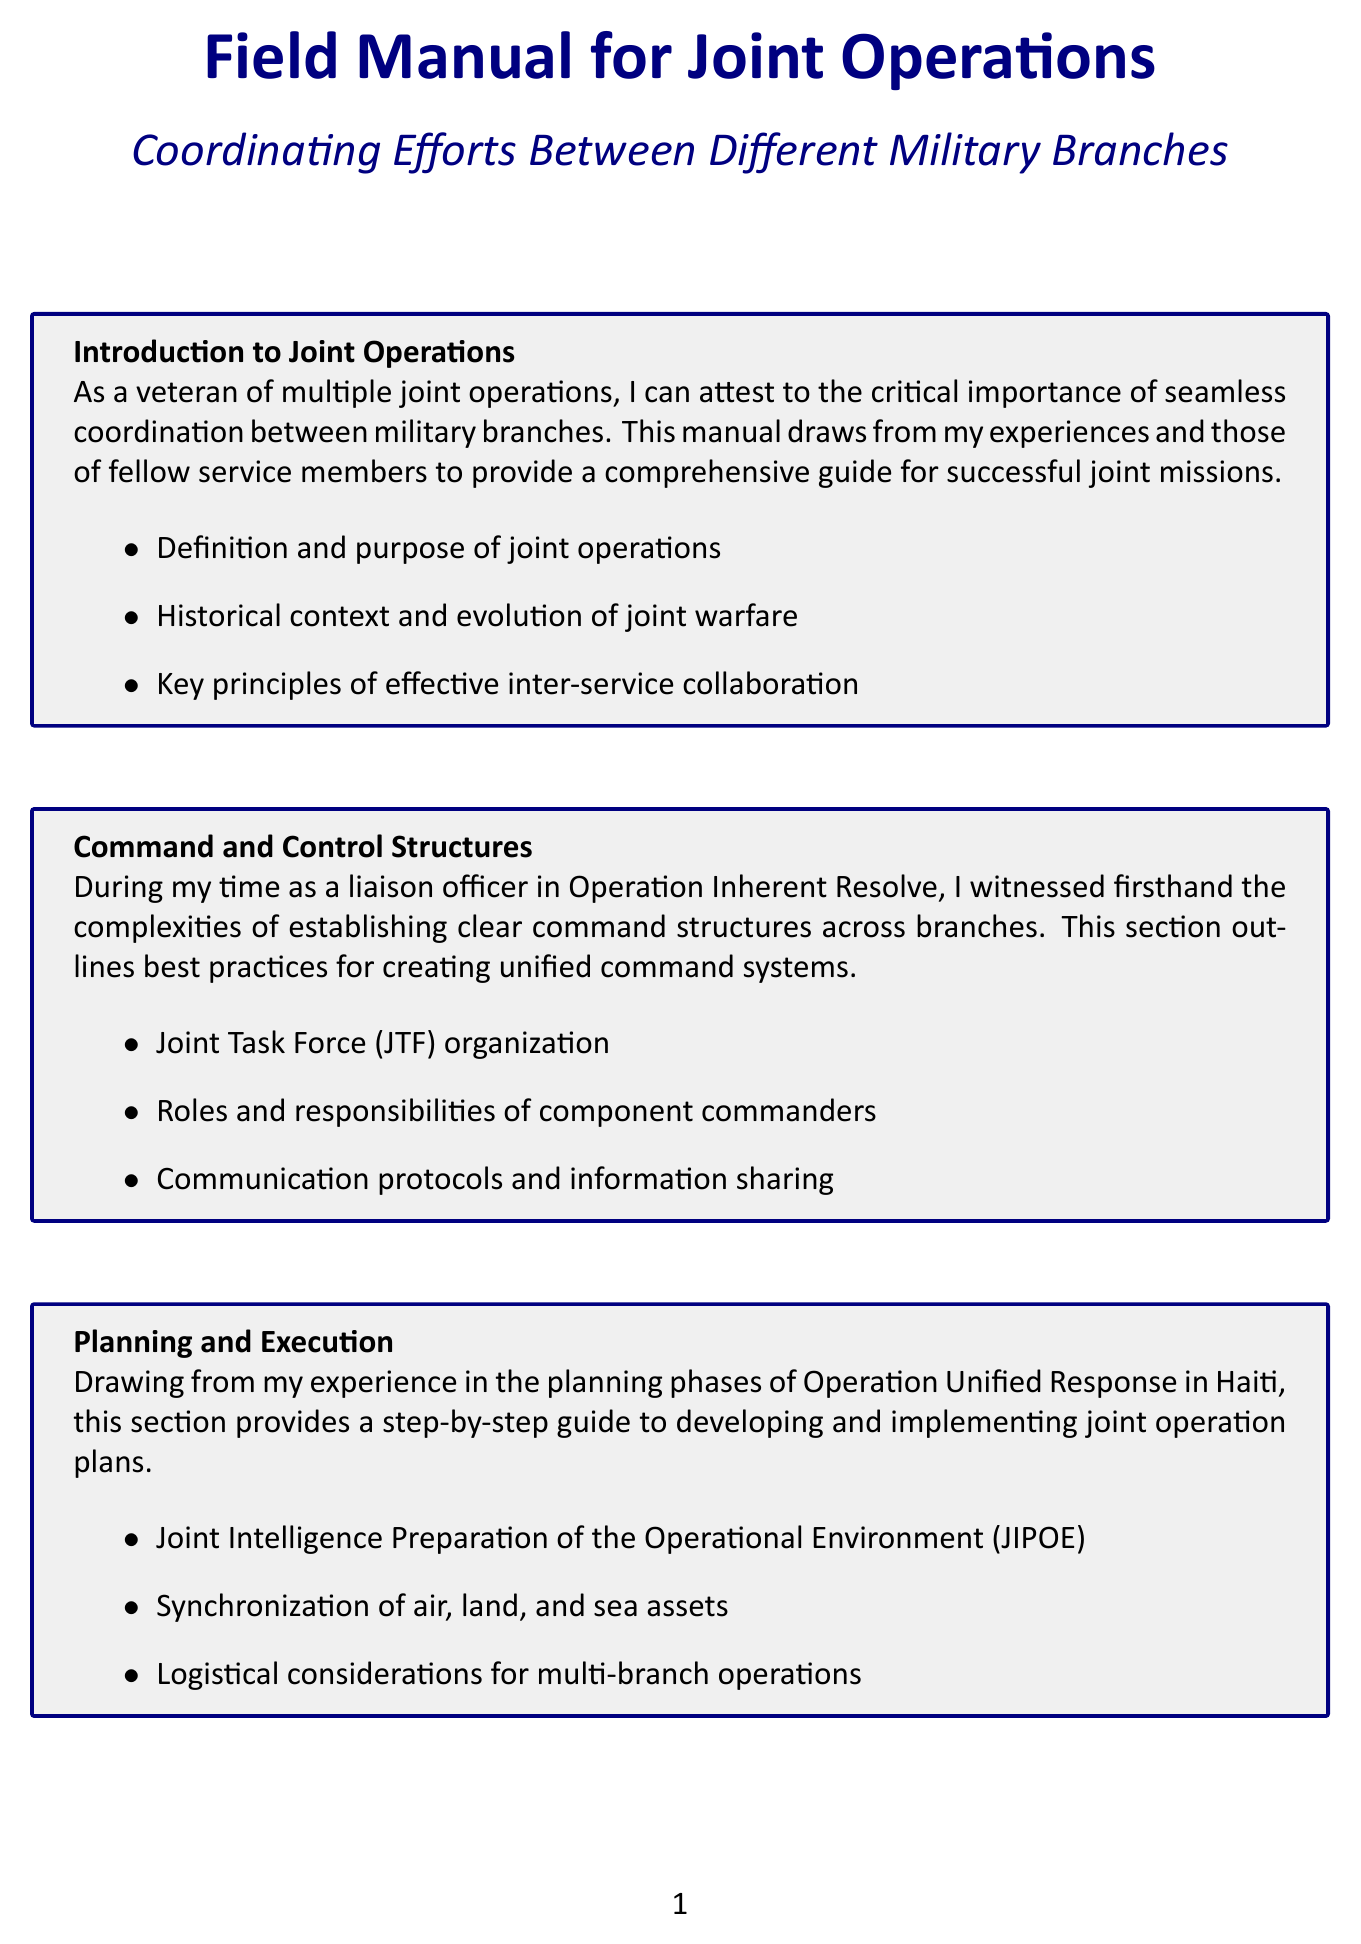What is the title of the manual? The title of the manual is stated at the beginning of the document.
Answer: Field Manual for Joint Operations What is the purpose of joint operations? The purpose of joint operations is defined in the introduction section of the document.
Answer: Seamless coordination between military branches Which operation involved the liberation of Kuwait? The document provides multiple case studies, one of which relates to the liberation of Kuwait.
Answer: Operation Desert Storm What year did Operation Neptune Spear occur? The document lists case studies along with their respective years, including Operation Neptune Spear.
Answer: 2011 What are the three key aspects addressed under interoperability? These aspects are outlined in the interoperability section.
Answer: Compatible communication systems and protocols; Standardization of equipment and procedures; Cross-training and personnel exchanges What is a major challenge discussed regarding joint operations? The document enumerates common obstacles and solutions identified during real-world operations.
Answer: Cultural differences between service branches How can future joint operations be characterized? The document discusses emerging technologies and trends affecting future operations.
Answer: Integration of cyber and space domains What is included in the appendices section? The appendices provide additional resources that support joint operations.
Answer: Glossary of joint operation terms and acronyms; Templates for joint operation orders; Checklists for pre-mission coordination; Contact information for joint operation centers and liaisons 